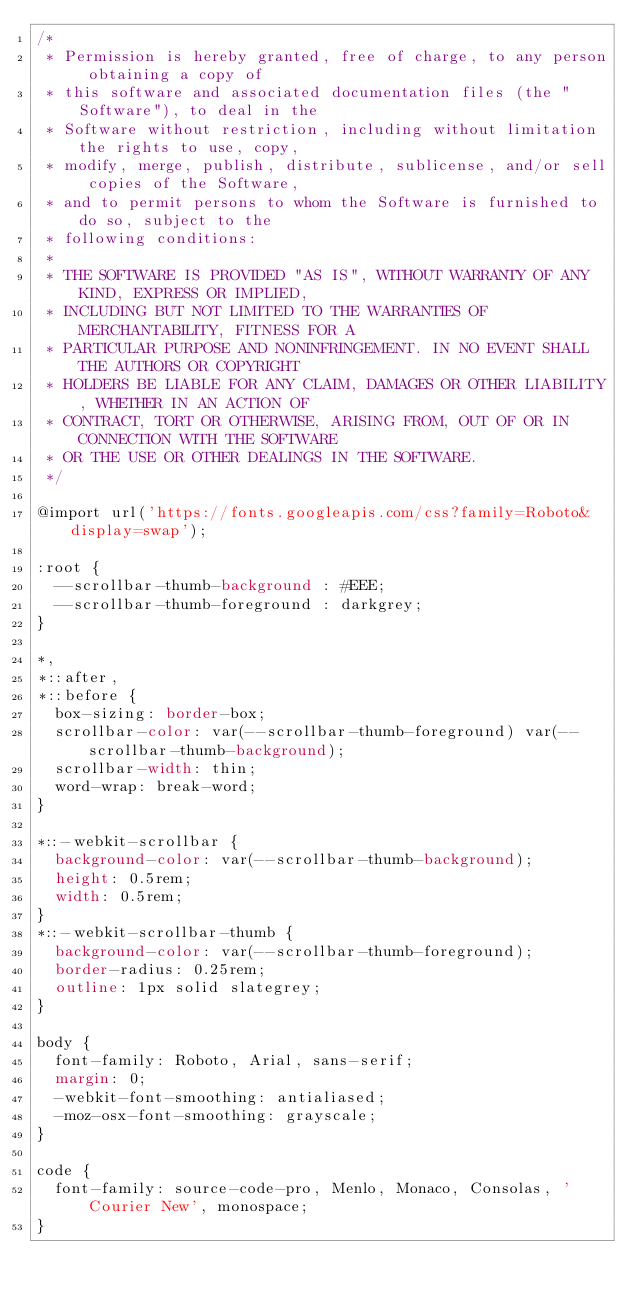Convert code to text. <code><loc_0><loc_0><loc_500><loc_500><_CSS_>/*
 * Permission is hereby granted, free of charge, to any person obtaining a copy of
 * this software and associated documentation files (the "Software"), to deal in the
 * Software without restriction, including without limitation the rights to use, copy,
 * modify, merge, publish, distribute, sublicense, and/or sell copies of the Software,
 * and to permit persons to whom the Software is furnished to do so, subject to the
 * following conditions:
 *
 * THE SOFTWARE IS PROVIDED "AS IS", WITHOUT WARRANTY OF ANY KIND, EXPRESS OR IMPLIED,
 * INCLUDING BUT NOT LIMITED TO THE WARRANTIES OF MERCHANTABILITY, FITNESS FOR A
 * PARTICULAR PURPOSE AND NONINFRINGEMENT. IN NO EVENT SHALL THE AUTHORS OR COPYRIGHT
 * HOLDERS BE LIABLE FOR ANY CLAIM, DAMAGES OR OTHER LIABILITY, WHETHER IN AN ACTION OF
 * CONTRACT, TORT OR OTHERWISE, ARISING FROM, OUT OF OR IN CONNECTION WITH THE SOFTWARE
 * OR THE USE OR OTHER DEALINGS IN THE SOFTWARE.
 */

@import url('https://fonts.googleapis.com/css?family=Roboto&display=swap');

:root {
  --scrollbar-thumb-background : #EEE;
  --scrollbar-thumb-foreground : darkgrey;
}

*,
*::after,
*::before {
  box-sizing: border-box;
  scrollbar-color: var(--scrollbar-thumb-foreground) var(--scrollbar-thumb-background);
  scrollbar-width: thin;
  word-wrap: break-word;
}

*::-webkit-scrollbar {
  background-color: var(--scrollbar-thumb-background);
  height: 0.5rem;
  width: 0.5rem;
}
*::-webkit-scrollbar-thumb {
  background-color: var(--scrollbar-thumb-foreground);
  border-radius: 0.25rem;
  outline: 1px solid slategrey;
}

body {
  font-family: Roboto, Arial, sans-serif;
  margin: 0;
  -webkit-font-smoothing: antialiased;
  -moz-osx-font-smoothing: grayscale;
}

code {
  font-family: source-code-pro, Menlo, Monaco, Consolas, 'Courier New', monospace;
}</code> 